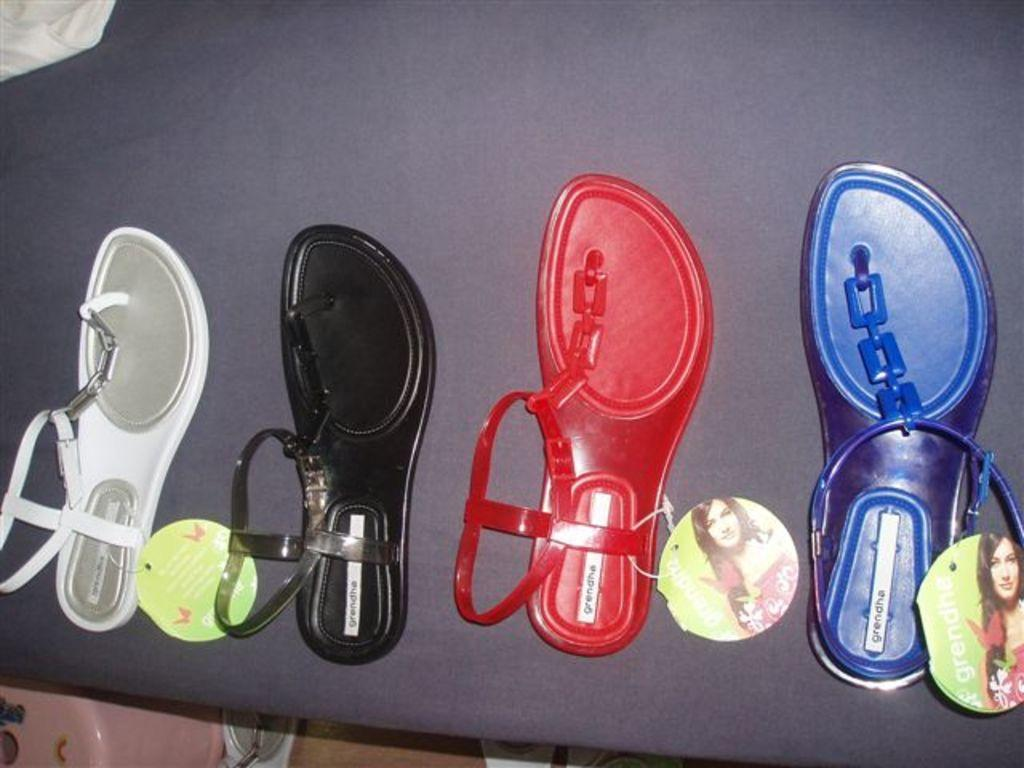What piece of furniture is present in the image? There is a table in the image. What items are placed on the table? There are sandals on the table. What type of seating is visible in the image? There is a stool at the bottom of the image. What can be seen on the left side of the image? There is a cloth on the left side of the image. How many lizards are playing basketball on the table in the image? There are no lizards or basketballs present in the image; it only features a table, sandals, a stool, and a cloth. 